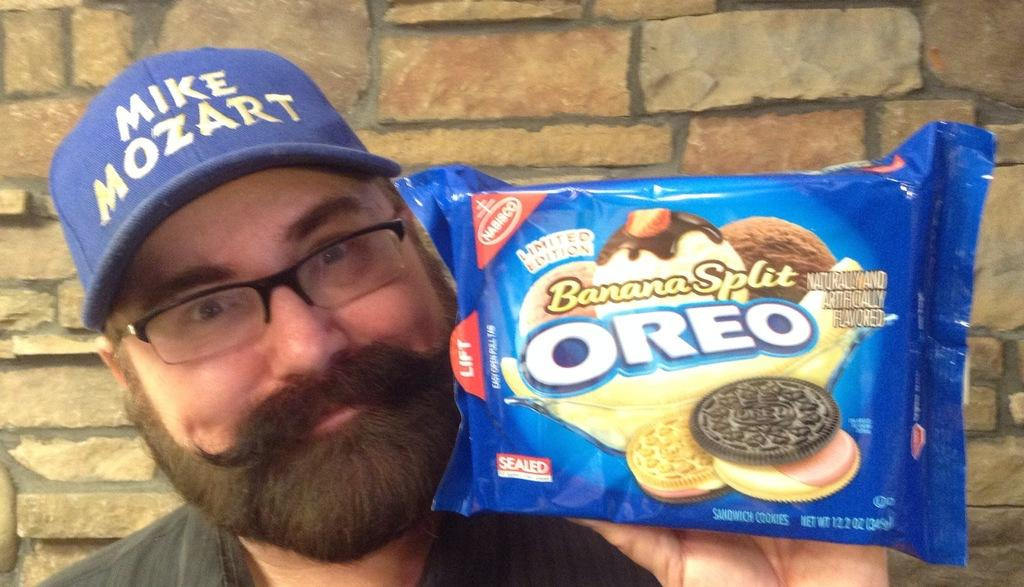Who is present in the image? There is a man in the image. What is the man doing in the image? The man is smiling in the image. What is the man holding in the image? The man is holding a biscuit packet in the image. What can be seen in the background of the image? There is a wall in the background of the image. What type of paste is the man using to stick the scissors on the wall in the image? There is no paste, scissors, or any activity involving them present in the image. 